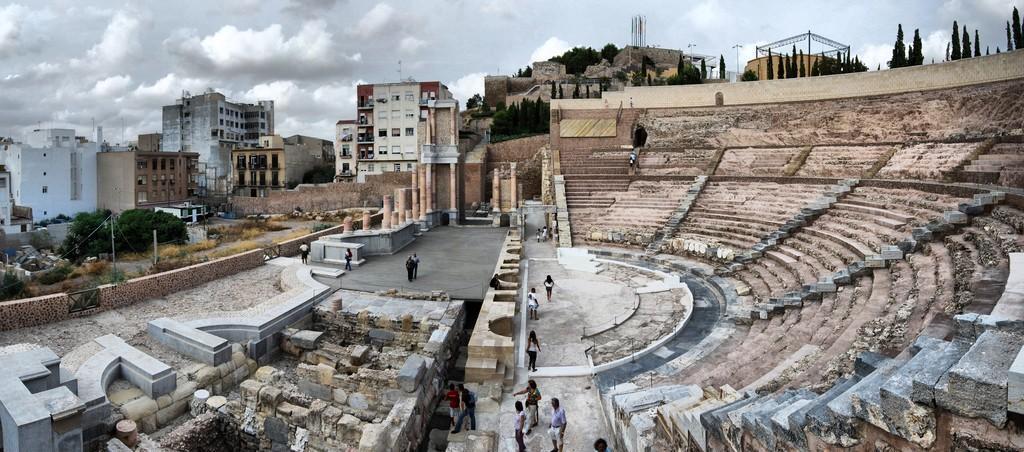In one or two sentences, can you explain what this image depicts? At the bottom of the image there are stone walls, pillars, and few people are standing on the floor. At the right corner of the image there are stones steps and above the steps there are trees. In the background there are buildings with walls and windows. Also there are many trees. At the top of the image there is a sky. 